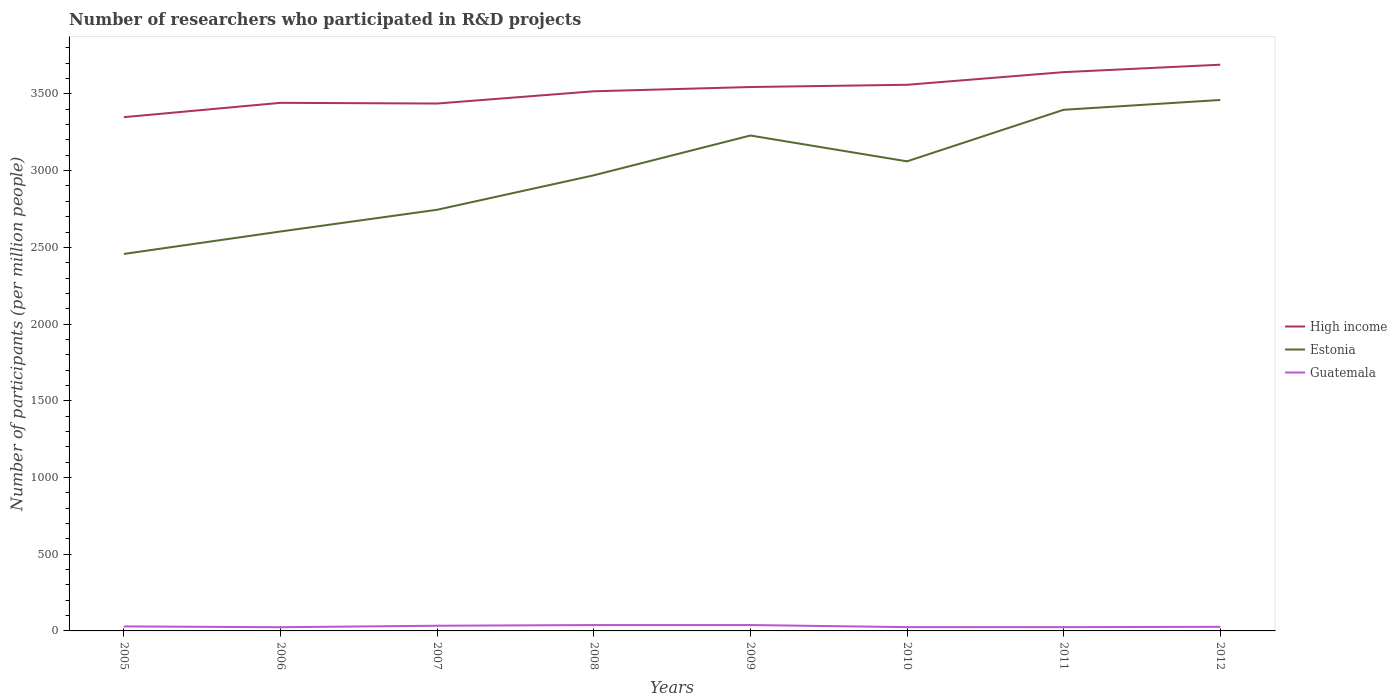How many different coloured lines are there?
Give a very brief answer. 3. Is the number of lines equal to the number of legend labels?
Make the answer very short. Yes. Across all years, what is the maximum number of researchers who participated in R&D projects in Guatemala?
Ensure brevity in your answer.  24.09. What is the total number of researchers who participated in R&D projects in Estonia in the graph?
Give a very brief answer. -483.95. What is the difference between the highest and the second highest number of researchers who participated in R&D projects in Guatemala?
Give a very brief answer. 14.33. Are the values on the major ticks of Y-axis written in scientific E-notation?
Offer a very short reply. No. Where does the legend appear in the graph?
Give a very brief answer. Center right. How many legend labels are there?
Give a very brief answer. 3. What is the title of the graph?
Your response must be concise. Number of researchers who participated in R&D projects. Does "Montenegro" appear as one of the legend labels in the graph?
Offer a terse response. No. What is the label or title of the Y-axis?
Provide a succinct answer. Number of participants (per million people). What is the Number of participants (per million people) in High income in 2005?
Provide a succinct answer. 3348.65. What is the Number of participants (per million people) in Estonia in 2005?
Keep it short and to the point. 2457.1. What is the Number of participants (per million people) of Guatemala in 2005?
Make the answer very short. 29.43. What is the Number of participants (per million people) of High income in 2006?
Make the answer very short. 3442.03. What is the Number of participants (per million people) of Estonia in 2006?
Your answer should be compact. 2603.44. What is the Number of participants (per million people) of Guatemala in 2006?
Keep it short and to the point. 24.09. What is the Number of participants (per million people) of High income in 2007?
Keep it short and to the point. 3437.47. What is the Number of participants (per million people) of Estonia in 2007?
Give a very brief answer. 2745.06. What is the Number of participants (per million people) in Guatemala in 2007?
Your response must be concise. 33.85. What is the Number of participants (per million people) of High income in 2008?
Your response must be concise. 3517.27. What is the Number of participants (per million people) of Estonia in 2008?
Give a very brief answer. 2969.53. What is the Number of participants (per million people) in Guatemala in 2008?
Your answer should be compact. 38.28. What is the Number of participants (per million people) of High income in 2009?
Your response must be concise. 3544.95. What is the Number of participants (per million people) in Estonia in 2009?
Ensure brevity in your answer.  3229.01. What is the Number of participants (per million people) of Guatemala in 2009?
Provide a succinct answer. 38.42. What is the Number of participants (per million people) of High income in 2010?
Your answer should be compact. 3559.6. What is the Number of participants (per million people) of Estonia in 2010?
Your answer should be compact. 3060.61. What is the Number of participants (per million people) of Guatemala in 2010?
Keep it short and to the point. 24.64. What is the Number of participants (per million people) of High income in 2011?
Ensure brevity in your answer.  3642.07. What is the Number of participants (per million people) of Estonia in 2011?
Provide a succinct answer. 3396.66. What is the Number of participants (per million people) of Guatemala in 2011?
Your answer should be compact. 24.59. What is the Number of participants (per million people) in High income in 2012?
Offer a terse response. 3690.53. What is the Number of participants (per million people) in Estonia in 2012?
Ensure brevity in your answer.  3460.62. What is the Number of participants (per million people) of Guatemala in 2012?
Keep it short and to the point. 26.74. Across all years, what is the maximum Number of participants (per million people) in High income?
Your response must be concise. 3690.53. Across all years, what is the maximum Number of participants (per million people) in Estonia?
Your answer should be compact. 3460.62. Across all years, what is the maximum Number of participants (per million people) in Guatemala?
Keep it short and to the point. 38.42. Across all years, what is the minimum Number of participants (per million people) in High income?
Give a very brief answer. 3348.65. Across all years, what is the minimum Number of participants (per million people) in Estonia?
Provide a succinct answer. 2457.1. Across all years, what is the minimum Number of participants (per million people) of Guatemala?
Offer a terse response. 24.09. What is the total Number of participants (per million people) in High income in the graph?
Your answer should be compact. 2.82e+04. What is the total Number of participants (per million people) of Estonia in the graph?
Make the answer very short. 2.39e+04. What is the total Number of participants (per million people) of Guatemala in the graph?
Provide a short and direct response. 240.04. What is the difference between the Number of participants (per million people) in High income in 2005 and that in 2006?
Provide a succinct answer. -93.37. What is the difference between the Number of participants (per million people) in Estonia in 2005 and that in 2006?
Provide a short and direct response. -146.34. What is the difference between the Number of participants (per million people) of Guatemala in 2005 and that in 2006?
Your answer should be very brief. 5.34. What is the difference between the Number of participants (per million people) in High income in 2005 and that in 2007?
Provide a succinct answer. -88.82. What is the difference between the Number of participants (per million people) of Estonia in 2005 and that in 2007?
Keep it short and to the point. -287.96. What is the difference between the Number of participants (per million people) in Guatemala in 2005 and that in 2007?
Provide a succinct answer. -4.42. What is the difference between the Number of participants (per million people) in High income in 2005 and that in 2008?
Your answer should be compact. -168.62. What is the difference between the Number of participants (per million people) in Estonia in 2005 and that in 2008?
Ensure brevity in your answer.  -512.43. What is the difference between the Number of participants (per million people) of Guatemala in 2005 and that in 2008?
Keep it short and to the point. -8.85. What is the difference between the Number of participants (per million people) of High income in 2005 and that in 2009?
Ensure brevity in your answer.  -196.3. What is the difference between the Number of participants (per million people) of Estonia in 2005 and that in 2009?
Keep it short and to the point. -771.91. What is the difference between the Number of participants (per million people) in Guatemala in 2005 and that in 2009?
Your response must be concise. -8.99. What is the difference between the Number of participants (per million people) in High income in 2005 and that in 2010?
Your answer should be very brief. -210.95. What is the difference between the Number of participants (per million people) in Estonia in 2005 and that in 2010?
Ensure brevity in your answer.  -603.5. What is the difference between the Number of participants (per million people) of Guatemala in 2005 and that in 2010?
Provide a succinct answer. 4.79. What is the difference between the Number of participants (per million people) in High income in 2005 and that in 2011?
Make the answer very short. -293.42. What is the difference between the Number of participants (per million people) of Estonia in 2005 and that in 2011?
Your answer should be very brief. -939.56. What is the difference between the Number of participants (per million people) of Guatemala in 2005 and that in 2011?
Ensure brevity in your answer.  4.84. What is the difference between the Number of participants (per million people) in High income in 2005 and that in 2012?
Offer a very short reply. -341.87. What is the difference between the Number of participants (per million people) in Estonia in 2005 and that in 2012?
Your response must be concise. -1003.52. What is the difference between the Number of participants (per million people) in Guatemala in 2005 and that in 2012?
Make the answer very short. 2.69. What is the difference between the Number of participants (per million people) in High income in 2006 and that in 2007?
Keep it short and to the point. 4.56. What is the difference between the Number of participants (per million people) of Estonia in 2006 and that in 2007?
Keep it short and to the point. -141.62. What is the difference between the Number of participants (per million people) in Guatemala in 2006 and that in 2007?
Provide a short and direct response. -9.75. What is the difference between the Number of participants (per million people) of High income in 2006 and that in 2008?
Provide a short and direct response. -75.24. What is the difference between the Number of participants (per million people) of Estonia in 2006 and that in 2008?
Keep it short and to the point. -366.09. What is the difference between the Number of participants (per million people) in Guatemala in 2006 and that in 2008?
Ensure brevity in your answer.  -14.19. What is the difference between the Number of participants (per million people) in High income in 2006 and that in 2009?
Give a very brief answer. -102.93. What is the difference between the Number of participants (per million people) of Estonia in 2006 and that in 2009?
Provide a short and direct response. -625.57. What is the difference between the Number of participants (per million people) of Guatemala in 2006 and that in 2009?
Your answer should be very brief. -14.33. What is the difference between the Number of participants (per million people) in High income in 2006 and that in 2010?
Keep it short and to the point. -117.57. What is the difference between the Number of participants (per million people) in Estonia in 2006 and that in 2010?
Make the answer very short. -457.17. What is the difference between the Number of participants (per million people) in Guatemala in 2006 and that in 2010?
Offer a very short reply. -0.55. What is the difference between the Number of participants (per million people) of High income in 2006 and that in 2011?
Provide a short and direct response. -200.05. What is the difference between the Number of participants (per million people) of Estonia in 2006 and that in 2011?
Provide a succinct answer. -793.22. What is the difference between the Number of participants (per million people) of Guatemala in 2006 and that in 2011?
Offer a terse response. -0.49. What is the difference between the Number of participants (per million people) of High income in 2006 and that in 2012?
Provide a succinct answer. -248.5. What is the difference between the Number of participants (per million people) in Estonia in 2006 and that in 2012?
Your answer should be very brief. -857.18. What is the difference between the Number of participants (per million people) of Guatemala in 2006 and that in 2012?
Keep it short and to the point. -2.65. What is the difference between the Number of participants (per million people) in High income in 2007 and that in 2008?
Your answer should be very brief. -79.8. What is the difference between the Number of participants (per million people) of Estonia in 2007 and that in 2008?
Your answer should be compact. -224.47. What is the difference between the Number of participants (per million people) in Guatemala in 2007 and that in 2008?
Ensure brevity in your answer.  -4.43. What is the difference between the Number of participants (per million people) in High income in 2007 and that in 2009?
Make the answer very short. -107.48. What is the difference between the Number of participants (per million people) in Estonia in 2007 and that in 2009?
Make the answer very short. -483.95. What is the difference between the Number of participants (per million people) of Guatemala in 2007 and that in 2009?
Provide a short and direct response. -4.58. What is the difference between the Number of participants (per million people) of High income in 2007 and that in 2010?
Your answer should be compact. -122.13. What is the difference between the Number of participants (per million people) in Estonia in 2007 and that in 2010?
Make the answer very short. -315.55. What is the difference between the Number of participants (per million people) in Guatemala in 2007 and that in 2010?
Keep it short and to the point. 9.21. What is the difference between the Number of participants (per million people) of High income in 2007 and that in 2011?
Your response must be concise. -204.6. What is the difference between the Number of participants (per million people) in Estonia in 2007 and that in 2011?
Ensure brevity in your answer.  -651.6. What is the difference between the Number of participants (per million people) in Guatemala in 2007 and that in 2011?
Offer a very short reply. 9.26. What is the difference between the Number of participants (per million people) in High income in 2007 and that in 2012?
Keep it short and to the point. -253.06. What is the difference between the Number of participants (per million people) in Estonia in 2007 and that in 2012?
Your answer should be very brief. -715.56. What is the difference between the Number of participants (per million people) in Guatemala in 2007 and that in 2012?
Give a very brief answer. 7.1. What is the difference between the Number of participants (per million people) in High income in 2008 and that in 2009?
Ensure brevity in your answer.  -27.68. What is the difference between the Number of participants (per million people) of Estonia in 2008 and that in 2009?
Keep it short and to the point. -259.48. What is the difference between the Number of participants (per million people) of Guatemala in 2008 and that in 2009?
Your response must be concise. -0.14. What is the difference between the Number of participants (per million people) of High income in 2008 and that in 2010?
Provide a short and direct response. -42.33. What is the difference between the Number of participants (per million people) in Estonia in 2008 and that in 2010?
Your response must be concise. -91.07. What is the difference between the Number of participants (per million people) in Guatemala in 2008 and that in 2010?
Offer a terse response. 13.64. What is the difference between the Number of participants (per million people) of High income in 2008 and that in 2011?
Offer a terse response. -124.8. What is the difference between the Number of participants (per million people) of Estonia in 2008 and that in 2011?
Ensure brevity in your answer.  -427.13. What is the difference between the Number of participants (per million people) in Guatemala in 2008 and that in 2011?
Make the answer very short. 13.69. What is the difference between the Number of participants (per million people) in High income in 2008 and that in 2012?
Ensure brevity in your answer.  -173.26. What is the difference between the Number of participants (per million people) of Estonia in 2008 and that in 2012?
Give a very brief answer. -491.09. What is the difference between the Number of participants (per million people) of Guatemala in 2008 and that in 2012?
Provide a succinct answer. 11.54. What is the difference between the Number of participants (per million people) of High income in 2009 and that in 2010?
Your response must be concise. -14.65. What is the difference between the Number of participants (per million people) of Estonia in 2009 and that in 2010?
Offer a very short reply. 168.4. What is the difference between the Number of participants (per million people) in Guatemala in 2009 and that in 2010?
Give a very brief answer. 13.78. What is the difference between the Number of participants (per million people) in High income in 2009 and that in 2011?
Give a very brief answer. -97.12. What is the difference between the Number of participants (per million people) in Estonia in 2009 and that in 2011?
Give a very brief answer. -167.65. What is the difference between the Number of participants (per million people) of Guatemala in 2009 and that in 2011?
Your answer should be very brief. 13.84. What is the difference between the Number of participants (per million people) in High income in 2009 and that in 2012?
Offer a very short reply. -145.57. What is the difference between the Number of participants (per million people) of Estonia in 2009 and that in 2012?
Your answer should be very brief. -231.61. What is the difference between the Number of participants (per million people) of Guatemala in 2009 and that in 2012?
Provide a succinct answer. 11.68. What is the difference between the Number of participants (per million people) of High income in 2010 and that in 2011?
Ensure brevity in your answer.  -82.47. What is the difference between the Number of participants (per million people) of Estonia in 2010 and that in 2011?
Offer a very short reply. -336.06. What is the difference between the Number of participants (per million people) in Guatemala in 2010 and that in 2011?
Offer a terse response. 0.05. What is the difference between the Number of participants (per million people) of High income in 2010 and that in 2012?
Offer a very short reply. -130.93. What is the difference between the Number of participants (per million people) in Estonia in 2010 and that in 2012?
Offer a terse response. -400.01. What is the difference between the Number of participants (per million people) of Guatemala in 2010 and that in 2012?
Offer a very short reply. -2.1. What is the difference between the Number of participants (per million people) of High income in 2011 and that in 2012?
Your response must be concise. -48.46. What is the difference between the Number of participants (per million people) in Estonia in 2011 and that in 2012?
Make the answer very short. -63.96. What is the difference between the Number of participants (per million people) of Guatemala in 2011 and that in 2012?
Offer a very short reply. -2.16. What is the difference between the Number of participants (per million people) in High income in 2005 and the Number of participants (per million people) in Estonia in 2006?
Offer a terse response. 745.22. What is the difference between the Number of participants (per million people) in High income in 2005 and the Number of participants (per million people) in Guatemala in 2006?
Offer a very short reply. 3324.56. What is the difference between the Number of participants (per million people) of Estonia in 2005 and the Number of participants (per million people) of Guatemala in 2006?
Provide a short and direct response. 2433.01. What is the difference between the Number of participants (per million people) in High income in 2005 and the Number of participants (per million people) in Estonia in 2007?
Your answer should be compact. 603.59. What is the difference between the Number of participants (per million people) in High income in 2005 and the Number of participants (per million people) in Guatemala in 2007?
Offer a terse response. 3314.81. What is the difference between the Number of participants (per million people) in Estonia in 2005 and the Number of participants (per million people) in Guatemala in 2007?
Offer a very short reply. 2423.26. What is the difference between the Number of participants (per million people) in High income in 2005 and the Number of participants (per million people) in Estonia in 2008?
Ensure brevity in your answer.  379.12. What is the difference between the Number of participants (per million people) in High income in 2005 and the Number of participants (per million people) in Guatemala in 2008?
Provide a succinct answer. 3310.37. What is the difference between the Number of participants (per million people) of Estonia in 2005 and the Number of participants (per million people) of Guatemala in 2008?
Give a very brief answer. 2418.82. What is the difference between the Number of participants (per million people) in High income in 2005 and the Number of participants (per million people) in Estonia in 2009?
Make the answer very short. 119.64. What is the difference between the Number of participants (per million people) of High income in 2005 and the Number of participants (per million people) of Guatemala in 2009?
Ensure brevity in your answer.  3310.23. What is the difference between the Number of participants (per million people) of Estonia in 2005 and the Number of participants (per million people) of Guatemala in 2009?
Your answer should be compact. 2418.68. What is the difference between the Number of participants (per million people) of High income in 2005 and the Number of participants (per million people) of Estonia in 2010?
Your response must be concise. 288.05. What is the difference between the Number of participants (per million people) in High income in 2005 and the Number of participants (per million people) in Guatemala in 2010?
Offer a terse response. 3324.01. What is the difference between the Number of participants (per million people) in Estonia in 2005 and the Number of participants (per million people) in Guatemala in 2010?
Make the answer very short. 2432.46. What is the difference between the Number of participants (per million people) of High income in 2005 and the Number of participants (per million people) of Estonia in 2011?
Your answer should be compact. -48.01. What is the difference between the Number of participants (per million people) of High income in 2005 and the Number of participants (per million people) of Guatemala in 2011?
Give a very brief answer. 3324.07. What is the difference between the Number of participants (per million people) of Estonia in 2005 and the Number of participants (per million people) of Guatemala in 2011?
Your answer should be very brief. 2432.52. What is the difference between the Number of participants (per million people) of High income in 2005 and the Number of participants (per million people) of Estonia in 2012?
Give a very brief answer. -111.97. What is the difference between the Number of participants (per million people) of High income in 2005 and the Number of participants (per million people) of Guatemala in 2012?
Offer a terse response. 3321.91. What is the difference between the Number of participants (per million people) in Estonia in 2005 and the Number of participants (per million people) in Guatemala in 2012?
Your response must be concise. 2430.36. What is the difference between the Number of participants (per million people) in High income in 2006 and the Number of participants (per million people) in Estonia in 2007?
Give a very brief answer. 696.97. What is the difference between the Number of participants (per million people) in High income in 2006 and the Number of participants (per million people) in Guatemala in 2007?
Provide a succinct answer. 3408.18. What is the difference between the Number of participants (per million people) of Estonia in 2006 and the Number of participants (per million people) of Guatemala in 2007?
Offer a terse response. 2569.59. What is the difference between the Number of participants (per million people) of High income in 2006 and the Number of participants (per million people) of Estonia in 2008?
Your response must be concise. 472.49. What is the difference between the Number of participants (per million people) in High income in 2006 and the Number of participants (per million people) in Guatemala in 2008?
Your response must be concise. 3403.75. What is the difference between the Number of participants (per million people) in Estonia in 2006 and the Number of participants (per million people) in Guatemala in 2008?
Provide a short and direct response. 2565.16. What is the difference between the Number of participants (per million people) of High income in 2006 and the Number of participants (per million people) of Estonia in 2009?
Your answer should be very brief. 213.02. What is the difference between the Number of participants (per million people) of High income in 2006 and the Number of participants (per million people) of Guatemala in 2009?
Provide a succinct answer. 3403.6. What is the difference between the Number of participants (per million people) in Estonia in 2006 and the Number of participants (per million people) in Guatemala in 2009?
Offer a terse response. 2565.01. What is the difference between the Number of participants (per million people) of High income in 2006 and the Number of participants (per million people) of Estonia in 2010?
Provide a succinct answer. 381.42. What is the difference between the Number of participants (per million people) of High income in 2006 and the Number of participants (per million people) of Guatemala in 2010?
Your answer should be compact. 3417.39. What is the difference between the Number of participants (per million people) in Estonia in 2006 and the Number of participants (per million people) in Guatemala in 2010?
Provide a succinct answer. 2578.8. What is the difference between the Number of participants (per million people) in High income in 2006 and the Number of participants (per million people) in Estonia in 2011?
Make the answer very short. 45.36. What is the difference between the Number of participants (per million people) in High income in 2006 and the Number of participants (per million people) in Guatemala in 2011?
Your response must be concise. 3417.44. What is the difference between the Number of participants (per million people) of Estonia in 2006 and the Number of participants (per million people) of Guatemala in 2011?
Provide a succinct answer. 2578.85. What is the difference between the Number of participants (per million people) in High income in 2006 and the Number of participants (per million people) in Estonia in 2012?
Your answer should be very brief. -18.59. What is the difference between the Number of participants (per million people) of High income in 2006 and the Number of participants (per million people) of Guatemala in 2012?
Ensure brevity in your answer.  3415.28. What is the difference between the Number of participants (per million people) in Estonia in 2006 and the Number of participants (per million people) in Guatemala in 2012?
Ensure brevity in your answer.  2576.7. What is the difference between the Number of participants (per million people) in High income in 2007 and the Number of participants (per million people) in Estonia in 2008?
Ensure brevity in your answer.  467.94. What is the difference between the Number of participants (per million people) in High income in 2007 and the Number of participants (per million people) in Guatemala in 2008?
Offer a terse response. 3399.19. What is the difference between the Number of participants (per million people) in Estonia in 2007 and the Number of participants (per million people) in Guatemala in 2008?
Ensure brevity in your answer.  2706.78. What is the difference between the Number of participants (per million people) in High income in 2007 and the Number of participants (per million people) in Estonia in 2009?
Offer a terse response. 208.46. What is the difference between the Number of participants (per million people) in High income in 2007 and the Number of participants (per million people) in Guatemala in 2009?
Make the answer very short. 3399.05. What is the difference between the Number of participants (per million people) in Estonia in 2007 and the Number of participants (per million people) in Guatemala in 2009?
Your answer should be compact. 2706.64. What is the difference between the Number of participants (per million people) of High income in 2007 and the Number of participants (per million people) of Estonia in 2010?
Your answer should be very brief. 376.86. What is the difference between the Number of participants (per million people) of High income in 2007 and the Number of participants (per million people) of Guatemala in 2010?
Offer a terse response. 3412.83. What is the difference between the Number of participants (per million people) of Estonia in 2007 and the Number of participants (per million people) of Guatemala in 2010?
Keep it short and to the point. 2720.42. What is the difference between the Number of participants (per million people) of High income in 2007 and the Number of participants (per million people) of Estonia in 2011?
Your response must be concise. 40.81. What is the difference between the Number of participants (per million people) of High income in 2007 and the Number of participants (per million people) of Guatemala in 2011?
Your answer should be compact. 3412.88. What is the difference between the Number of participants (per million people) of Estonia in 2007 and the Number of participants (per million people) of Guatemala in 2011?
Your answer should be very brief. 2720.47. What is the difference between the Number of participants (per million people) in High income in 2007 and the Number of participants (per million people) in Estonia in 2012?
Your response must be concise. -23.15. What is the difference between the Number of participants (per million people) of High income in 2007 and the Number of participants (per million people) of Guatemala in 2012?
Provide a short and direct response. 3410.73. What is the difference between the Number of participants (per million people) in Estonia in 2007 and the Number of participants (per million people) in Guatemala in 2012?
Offer a very short reply. 2718.32. What is the difference between the Number of participants (per million people) in High income in 2008 and the Number of participants (per million people) in Estonia in 2009?
Your response must be concise. 288.26. What is the difference between the Number of participants (per million people) in High income in 2008 and the Number of participants (per million people) in Guatemala in 2009?
Offer a terse response. 3478.85. What is the difference between the Number of participants (per million people) in Estonia in 2008 and the Number of participants (per million people) in Guatemala in 2009?
Ensure brevity in your answer.  2931.11. What is the difference between the Number of participants (per million people) of High income in 2008 and the Number of participants (per million people) of Estonia in 2010?
Your answer should be compact. 456.66. What is the difference between the Number of participants (per million people) in High income in 2008 and the Number of participants (per million people) in Guatemala in 2010?
Give a very brief answer. 3492.63. What is the difference between the Number of participants (per million people) in Estonia in 2008 and the Number of participants (per million people) in Guatemala in 2010?
Give a very brief answer. 2944.89. What is the difference between the Number of participants (per million people) in High income in 2008 and the Number of participants (per million people) in Estonia in 2011?
Offer a terse response. 120.61. What is the difference between the Number of participants (per million people) in High income in 2008 and the Number of participants (per million people) in Guatemala in 2011?
Your response must be concise. 3492.68. What is the difference between the Number of participants (per million people) in Estonia in 2008 and the Number of participants (per million people) in Guatemala in 2011?
Make the answer very short. 2944.95. What is the difference between the Number of participants (per million people) in High income in 2008 and the Number of participants (per million people) in Estonia in 2012?
Offer a terse response. 56.65. What is the difference between the Number of participants (per million people) in High income in 2008 and the Number of participants (per million people) in Guatemala in 2012?
Offer a very short reply. 3490.53. What is the difference between the Number of participants (per million people) in Estonia in 2008 and the Number of participants (per million people) in Guatemala in 2012?
Make the answer very short. 2942.79. What is the difference between the Number of participants (per million people) in High income in 2009 and the Number of participants (per million people) in Estonia in 2010?
Ensure brevity in your answer.  484.35. What is the difference between the Number of participants (per million people) of High income in 2009 and the Number of participants (per million people) of Guatemala in 2010?
Ensure brevity in your answer.  3520.31. What is the difference between the Number of participants (per million people) in Estonia in 2009 and the Number of participants (per million people) in Guatemala in 2010?
Ensure brevity in your answer.  3204.37. What is the difference between the Number of participants (per million people) in High income in 2009 and the Number of participants (per million people) in Estonia in 2011?
Your answer should be very brief. 148.29. What is the difference between the Number of participants (per million people) in High income in 2009 and the Number of participants (per million people) in Guatemala in 2011?
Your answer should be very brief. 3520.37. What is the difference between the Number of participants (per million people) of Estonia in 2009 and the Number of participants (per million people) of Guatemala in 2011?
Make the answer very short. 3204.42. What is the difference between the Number of participants (per million people) in High income in 2009 and the Number of participants (per million people) in Estonia in 2012?
Your answer should be compact. 84.33. What is the difference between the Number of participants (per million people) in High income in 2009 and the Number of participants (per million people) in Guatemala in 2012?
Keep it short and to the point. 3518.21. What is the difference between the Number of participants (per million people) of Estonia in 2009 and the Number of participants (per million people) of Guatemala in 2012?
Offer a terse response. 3202.27. What is the difference between the Number of participants (per million people) of High income in 2010 and the Number of participants (per million people) of Estonia in 2011?
Keep it short and to the point. 162.94. What is the difference between the Number of participants (per million people) of High income in 2010 and the Number of participants (per million people) of Guatemala in 2011?
Provide a short and direct response. 3535.01. What is the difference between the Number of participants (per million people) in Estonia in 2010 and the Number of participants (per million people) in Guatemala in 2011?
Make the answer very short. 3036.02. What is the difference between the Number of participants (per million people) of High income in 2010 and the Number of participants (per million people) of Estonia in 2012?
Offer a very short reply. 98.98. What is the difference between the Number of participants (per million people) in High income in 2010 and the Number of participants (per million people) in Guatemala in 2012?
Offer a very short reply. 3532.86. What is the difference between the Number of participants (per million people) of Estonia in 2010 and the Number of participants (per million people) of Guatemala in 2012?
Provide a succinct answer. 3033.86. What is the difference between the Number of participants (per million people) of High income in 2011 and the Number of participants (per million people) of Estonia in 2012?
Your answer should be compact. 181.45. What is the difference between the Number of participants (per million people) of High income in 2011 and the Number of participants (per million people) of Guatemala in 2012?
Give a very brief answer. 3615.33. What is the difference between the Number of participants (per million people) in Estonia in 2011 and the Number of participants (per million people) in Guatemala in 2012?
Give a very brief answer. 3369.92. What is the average Number of participants (per million people) of High income per year?
Your response must be concise. 3522.82. What is the average Number of participants (per million people) of Estonia per year?
Provide a short and direct response. 2990.25. What is the average Number of participants (per million people) of Guatemala per year?
Make the answer very short. 30.01. In the year 2005, what is the difference between the Number of participants (per million people) of High income and Number of participants (per million people) of Estonia?
Offer a terse response. 891.55. In the year 2005, what is the difference between the Number of participants (per million people) of High income and Number of participants (per million people) of Guatemala?
Give a very brief answer. 3319.22. In the year 2005, what is the difference between the Number of participants (per million people) in Estonia and Number of participants (per million people) in Guatemala?
Your answer should be compact. 2427.67. In the year 2006, what is the difference between the Number of participants (per million people) in High income and Number of participants (per million people) in Estonia?
Your answer should be very brief. 838.59. In the year 2006, what is the difference between the Number of participants (per million people) of High income and Number of participants (per million people) of Guatemala?
Ensure brevity in your answer.  3417.93. In the year 2006, what is the difference between the Number of participants (per million people) of Estonia and Number of participants (per million people) of Guatemala?
Keep it short and to the point. 2579.35. In the year 2007, what is the difference between the Number of participants (per million people) in High income and Number of participants (per million people) in Estonia?
Your answer should be very brief. 692.41. In the year 2007, what is the difference between the Number of participants (per million people) of High income and Number of participants (per million people) of Guatemala?
Ensure brevity in your answer.  3403.62. In the year 2007, what is the difference between the Number of participants (per million people) in Estonia and Number of participants (per million people) in Guatemala?
Your answer should be compact. 2711.21. In the year 2008, what is the difference between the Number of participants (per million people) in High income and Number of participants (per million people) in Estonia?
Offer a very short reply. 547.74. In the year 2008, what is the difference between the Number of participants (per million people) of High income and Number of participants (per million people) of Guatemala?
Your answer should be compact. 3478.99. In the year 2008, what is the difference between the Number of participants (per million people) in Estonia and Number of participants (per million people) in Guatemala?
Give a very brief answer. 2931.25. In the year 2009, what is the difference between the Number of participants (per million people) in High income and Number of participants (per million people) in Estonia?
Your answer should be very brief. 315.94. In the year 2009, what is the difference between the Number of participants (per million people) of High income and Number of participants (per million people) of Guatemala?
Your answer should be compact. 3506.53. In the year 2009, what is the difference between the Number of participants (per million people) in Estonia and Number of participants (per million people) in Guatemala?
Make the answer very short. 3190.59. In the year 2010, what is the difference between the Number of participants (per million people) in High income and Number of participants (per million people) in Estonia?
Give a very brief answer. 498.99. In the year 2010, what is the difference between the Number of participants (per million people) in High income and Number of participants (per million people) in Guatemala?
Your answer should be very brief. 3534.96. In the year 2010, what is the difference between the Number of participants (per million people) in Estonia and Number of participants (per million people) in Guatemala?
Give a very brief answer. 3035.97. In the year 2011, what is the difference between the Number of participants (per million people) in High income and Number of participants (per million people) in Estonia?
Ensure brevity in your answer.  245.41. In the year 2011, what is the difference between the Number of participants (per million people) in High income and Number of participants (per million people) in Guatemala?
Offer a very short reply. 3617.49. In the year 2011, what is the difference between the Number of participants (per million people) in Estonia and Number of participants (per million people) in Guatemala?
Offer a very short reply. 3372.08. In the year 2012, what is the difference between the Number of participants (per million people) of High income and Number of participants (per million people) of Estonia?
Offer a terse response. 229.91. In the year 2012, what is the difference between the Number of participants (per million people) in High income and Number of participants (per million people) in Guatemala?
Your answer should be compact. 3663.78. In the year 2012, what is the difference between the Number of participants (per million people) of Estonia and Number of participants (per million people) of Guatemala?
Provide a short and direct response. 3433.88. What is the ratio of the Number of participants (per million people) of High income in 2005 to that in 2006?
Keep it short and to the point. 0.97. What is the ratio of the Number of participants (per million people) in Estonia in 2005 to that in 2006?
Give a very brief answer. 0.94. What is the ratio of the Number of participants (per million people) of Guatemala in 2005 to that in 2006?
Offer a very short reply. 1.22. What is the ratio of the Number of participants (per million people) of High income in 2005 to that in 2007?
Provide a succinct answer. 0.97. What is the ratio of the Number of participants (per million people) in Estonia in 2005 to that in 2007?
Give a very brief answer. 0.9. What is the ratio of the Number of participants (per million people) of Guatemala in 2005 to that in 2007?
Give a very brief answer. 0.87. What is the ratio of the Number of participants (per million people) of High income in 2005 to that in 2008?
Your answer should be very brief. 0.95. What is the ratio of the Number of participants (per million people) in Estonia in 2005 to that in 2008?
Give a very brief answer. 0.83. What is the ratio of the Number of participants (per million people) in Guatemala in 2005 to that in 2008?
Offer a very short reply. 0.77. What is the ratio of the Number of participants (per million people) of High income in 2005 to that in 2009?
Give a very brief answer. 0.94. What is the ratio of the Number of participants (per million people) in Estonia in 2005 to that in 2009?
Offer a very short reply. 0.76. What is the ratio of the Number of participants (per million people) in Guatemala in 2005 to that in 2009?
Your answer should be very brief. 0.77. What is the ratio of the Number of participants (per million people) of High income in 2005 to that in 2010?
Your answer should be compact. 0.94. What is the ratio of the Number of participants (per million people) of Estonia in 2005 to that in 2010?
Provide a short and direct response. 0.8. What is the ratio of the Number of participants (per million people) of Guatemala in 2005 to that in 2010?
Your response must be concise. 1.19. What is the ratio of the Number of participants (per million people) of High income in 2005 to that in 2011?
Offer a very short reply. 0.92. What is the ratio of the Number of participants (per million people) of Estonia in 2005 to that in 2011?
Your response must be concise. 0.72. What is the ratio of the Number of participants (per million people) in Guatemala in 2005 to that in 2011?
Make the answer very short. 1.2. What is the ratio of the Number of participants (per million people) in High income in 2005 to that in 2012?
Your answer should be compact. 0.91. What is the ratio of the Number of participants (per million people) in Estonia in 2005 to that in 2012?
Offer a very short reply. 0.71. What is the ratio of the Number of participants (per million people) in Guatemala in 2005 to that in 2012?
Your answer should be very brief. 1.1. What is the ratio of the Number of participants (per million people) in High income in 2006 to that in 2007?
Provide a succinct answer. 1. What is the ratio of the Number of participants (per million people) in Estonia in 2006 to that in 2007?
Ensure brevity in your answer.  0.95. What is the ratio of the Number of participants (per million people) in Guatemala in 2006 to that in 2007?
Keep it short and to the point. 0.71. What is the ratio of the Number of participants (per million people) in High income in 2006 to that in 2008?
Provide a succinct answer. 0.98. What is the ratio of the Number of participants (per million people) in Estonia in 2006 to that in 2008?
Keep it short and to the point. 0.88. What is the ratio of the Number of participants (per million people) of Guatemala in 2006 to that in 2008?
Offer a terse response. 0.63. What is the ratio of the Number of participants (per million people) of High income in 2006 to that in 2009?
Your answer should be compact. 0.97. What is the ratio of the Number of participants (per million people) in Estonia in 2006 to that in 2009?
Offer a very short reply. 0.81. What is the ratio of the Number of participants (per million people) in Guatemala in 2006 to that in 2009?
Offer a very short reply. 0.63. What is the ratio of the Number of participants (per million people) of Estonia in 2006 to that in 2010?
Your answer should be compact. 0.85. What is the ratio of the Number of participants (per million people) of Guatemala in 2006 to that in 2010?
Provide a succinct answer. 0.98. What is the ratio of the Number of participants (per million people) of High income in 2006 to that in 2011?
Offer a terse response. 0.95. What is the ratio of the Number of participants (per million people) in Estonia in 2006 to that in 2011?
Provide a succinct answer. 0.77. What is the ratio of the Number of participants (per million people) of Guatemala in 2006 to that in 2011?
Provide a succinct answer. 0.98. What is the ratio of the Number of participants (per million people) in High income in 2006 to that in 2012?
Give a very brief answer. 0.93. What is the ratio of the Number of participants (per million people) of Estonia in 2006 to that in 2012?
Keep it short and to the point. 0.75. What is the ratio of the Number of participants (per million people) of Guatemala in 2006 to that in 2012?
Offer a terse response. 0.9. What is the ratio of the Number of participants (per million people) in High income in 2007 to that in 2008?
Provide a short and direct response. 0.98. What is the ratio of the Number of participants (per million people) in Estonia in 2007 to that in 2008?
Make the answer very short. 0.92. What is the ratio of the Number of participants (per million people) in Guatemala in 2007 to that in 2008?
Provide a short and direct response. 0.88. What is the ratio of the Number of participants (per million people) of High income in 2007 to that in 2009?
Your answer should be very brief. 0.97. What is the ratio of the Number of participants (per million people) of Estonia in 2007 to that in 2009?
Your response must be concise. 0.85. What is the ratio of the Number of participants (per million people) of Guatemala in 2007 to that in 2009?
Provide a short and direct response. 0.88. What is the ratio of the Number of participants (per million people) in High income in 2007 to that in 2010?
Keep it short and to the point. 0.97. What is the ratio of the Number of participants (per million people) in Estonia in 2007 to that in 2010?
Provide a short and direct response. 0.9. What is the ratio of the Number of participants (per million people) of Guatemala in 2007 to that in 2010?
Make the answer very short. 1.37. What is the ratio of the Number of participants (per million people) in High income in 2007 to that in 2011?
Provide a succinct answer. 0.94. What is the ratio of the Number of participants (per million people) in Estonia in 2007 to that in 2011?
Make the answer very short. 0.81. What is the ratio of the Number of participants (per million people) in Guatemala in 2007 to that in 2011?
Your answer should be compact. 1.38. What is the ratio of the Number of participants (per million people) of High income in 2007 to that in 2012?
Make the answer very short. 0.93. What is the ratio of the Number of participants (per million people) in Estonia in 2007 to that in 2012?
Your answer should be very brief. 0.79. What is the ratio of the Number of participants (per million people) in Guatemala in 2007 to that in 2012?
Your response must be concise. 1.27. What is the ratio of the Number of participants (per million people) of High income in 2008 to that in 2009?
Your response must be concise. 0.99. What is the ratio of the Number of participants (per million people) in Estonia in 2008 to that in 2009?
Provide a succinct answer. 0.92. What is the ratio of the Number of participants (per million people) in High income in 2008 to that in 2010?
Offer a terse response. 0.99. What is the ratio of the Number of participants (per million people) in Estonia in 2008 to that in 2010?
Make the answer very short. 0.97. What is the ratio of the Number of participants (per million people) of Guatemala in 2008 to that in 2010?
Keep it short and to the point. 1.55. What is the ratio of the Number of participants (per million people) in High income in 2008 to that in 2011?
Provide a succinct answer. 0.97. What is the ratio of the Number of participants (per million people) in Estonia in 2008 to that in 2011?
Provide a succinct answer. 0.87. What is the ratio of the Number of participants (per million people) of Guatemala in 2008 to that in 2011?
Your response must be concise. 1.56. What is the ratio of the Number of participants (per million people) in High income in 2008 to that in 2012?
Your answer should be very brief. 0.95. What is the ratio of the Number of participants (per million people) of Estonia in 2008 to that in 2012?
Your answer should be compact. 0.86. What is the ratio of the Number of participants (per million people) in Guatemala in 2008 to that in 2012?
Give a very brief answer. 1.43. What is the ratio of the Number of participants (per million people) in High income in 2009 to that in 2010?
Keep it short and to the point. 1. What is the ratio of the Number of participants (per million people) of Estonia in 2009 to that in 2010?
Make the answer very short. 1.05. What is the ratio of the Number of participants (per million people) in Guatemala in 2009 to that in 2010?
Your answer should be very brief. 1.56. What is the ratio of the Number of participants (per million people) of High income in 2009 to that in 2011?
Make the answer very short. 0.97. What is the ratio of the Number of participants (per million people) of Estonia in 2009 to that in 2011?
Give a very brief answer. 0.95. What is the ratio of the Number of participants (per million people) of Guatemala in 2009 to that in 2011?
Make the answer very short. 1.56. What is the ratio of the Number of participants (per million people) of High income in 2009 to that in 2012?
Your response must be concise. 0.96. What is the ratio of the Number of participants (per million people) of Estonia in 2009 to that in 2012?
Make the answer very short. 0.93. What is the ratio of the Number of participants (per million people) of Guatemala in 2009 to that in 2012?
Make the answer very short. 1.44. What is the ratio of the Number of participants (per million people) of High income in 2010 to that in 2011?
Provide a succinct answer. 0.98. What is the ratio of the Number of participants (per million people) in Estonia in 2010 to that in 2011?
Your response must be concise. 0.9. What is the ratio of the Number of participants (per million people) in Guatemala in 2010 to that in 2011?
Make the answer very short. 1. What is the ratio of the Number of participants (per million people) in High income in 2010 to that in 2012?
Provide a short and direct response. 0.96. What is the ratio of the Number of participants (per million people) in Estonia in 2010 to that in 2012?
Give a very brief answer. 0.88. What is the ratio of the Number of participants (per million people) in Guatemala in 2010 to that in 2012?
Your response must be concise. 0.92. What is the ratio of the Number of participants (per million people) in High income in 2011 to that in 2012?
Your response must be concise. 0.99. What is the ratio of the Number of participants (per million people) of Estonia in 2011 to that in 2012?
Provide a succinct answer. 0.98. What is the ratio of the Number of participants (per million people) of Guatemala in 2011 to that in 2012?
Provide a succinct answer. 0.92. What is the difference between the highest and the second highest Number of participants (per million people) of High income?
Your response must be concise. 48.46. What is the difference between the highest and the second highest Number of participants (per million people) in Estonia?
Ensure brevity in your answer.  63.96. What is the difference between the highest and the second highest Number of participants (per million people) in Guatemala?
Provide a succinct answer. 0.14. What is the difference between the highest and the lowest Number of participants (per million people) of High income?
Keep it short and to the point. 341.87. What is the difference between the highest and the lowest Number of participants (per million people) of Estonia?
Your response must be concise. 1003.52. What is the difference between the highest and the lowest Number of participants (per million people) in Guatemala?
Provide a short and direct response. 14.33. 